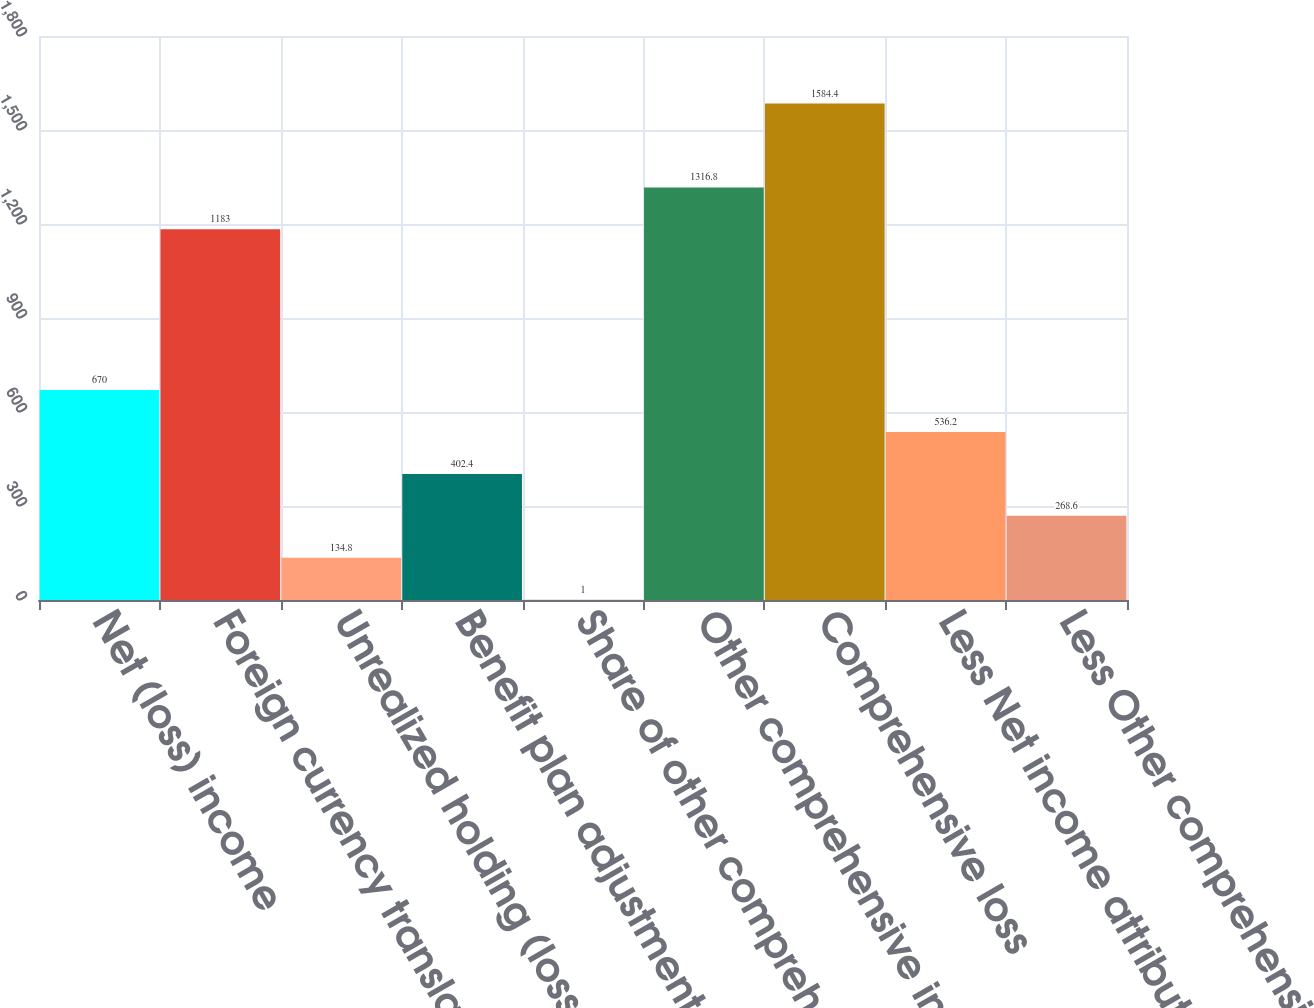<chart> <loc_0><loc_0><loc_500><loc_500><bar_chart><fcel>Net (loss) income<fcel>Foreign currency translation<fcel>Unrealized holding (losses)<fcel>Benefit plan adjustments net<fcel>Share of other comprehensive<fcel>Other comprehensive income<fcel>Comprehensive loss<fcel>Less Net income attributable<fcel>Less Other comprehensive loss<nl><fcel>670<fcel>1183<fcel>134.8<fcel>402.4<fcel>1<fcel>1316.8<fcel>1584.4<fcel>536.2<fcel>268.6<nl></chart> 